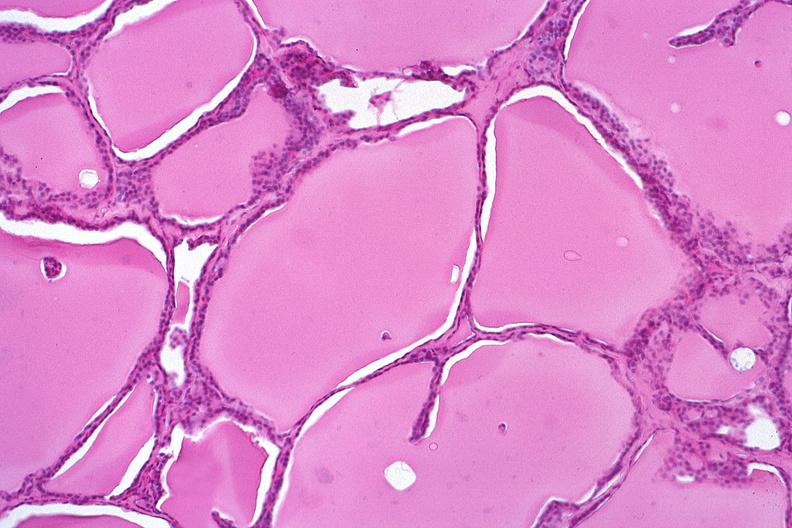does opened muscle show thyroid, normal?
Answer the question using a single word or phrase. No 